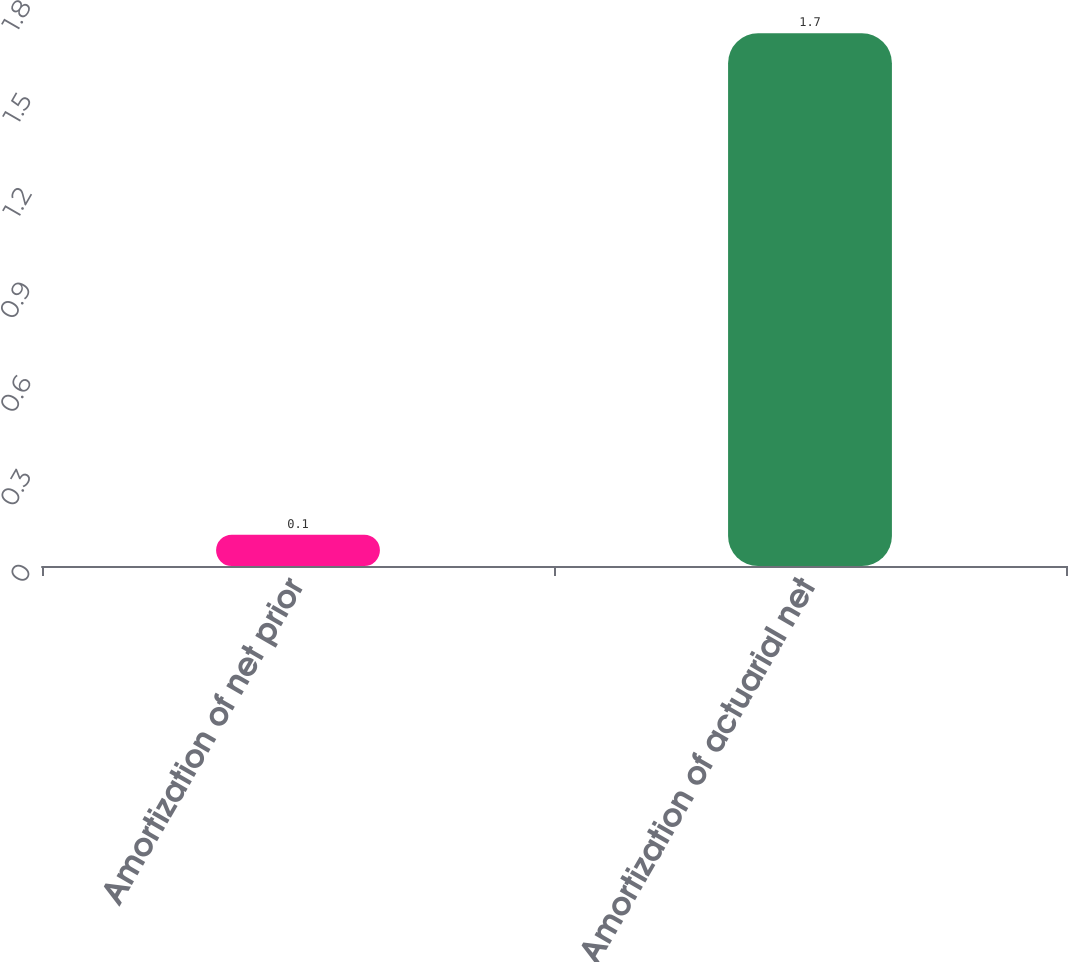<chart> <loc_0><loc_0><loc_500><loc_500><bar_chart><fcel>Amortization of net prior<fcel>Amortization of actuarial net<nl><fcel>0.1<fcel>1.7<nl></chart> 